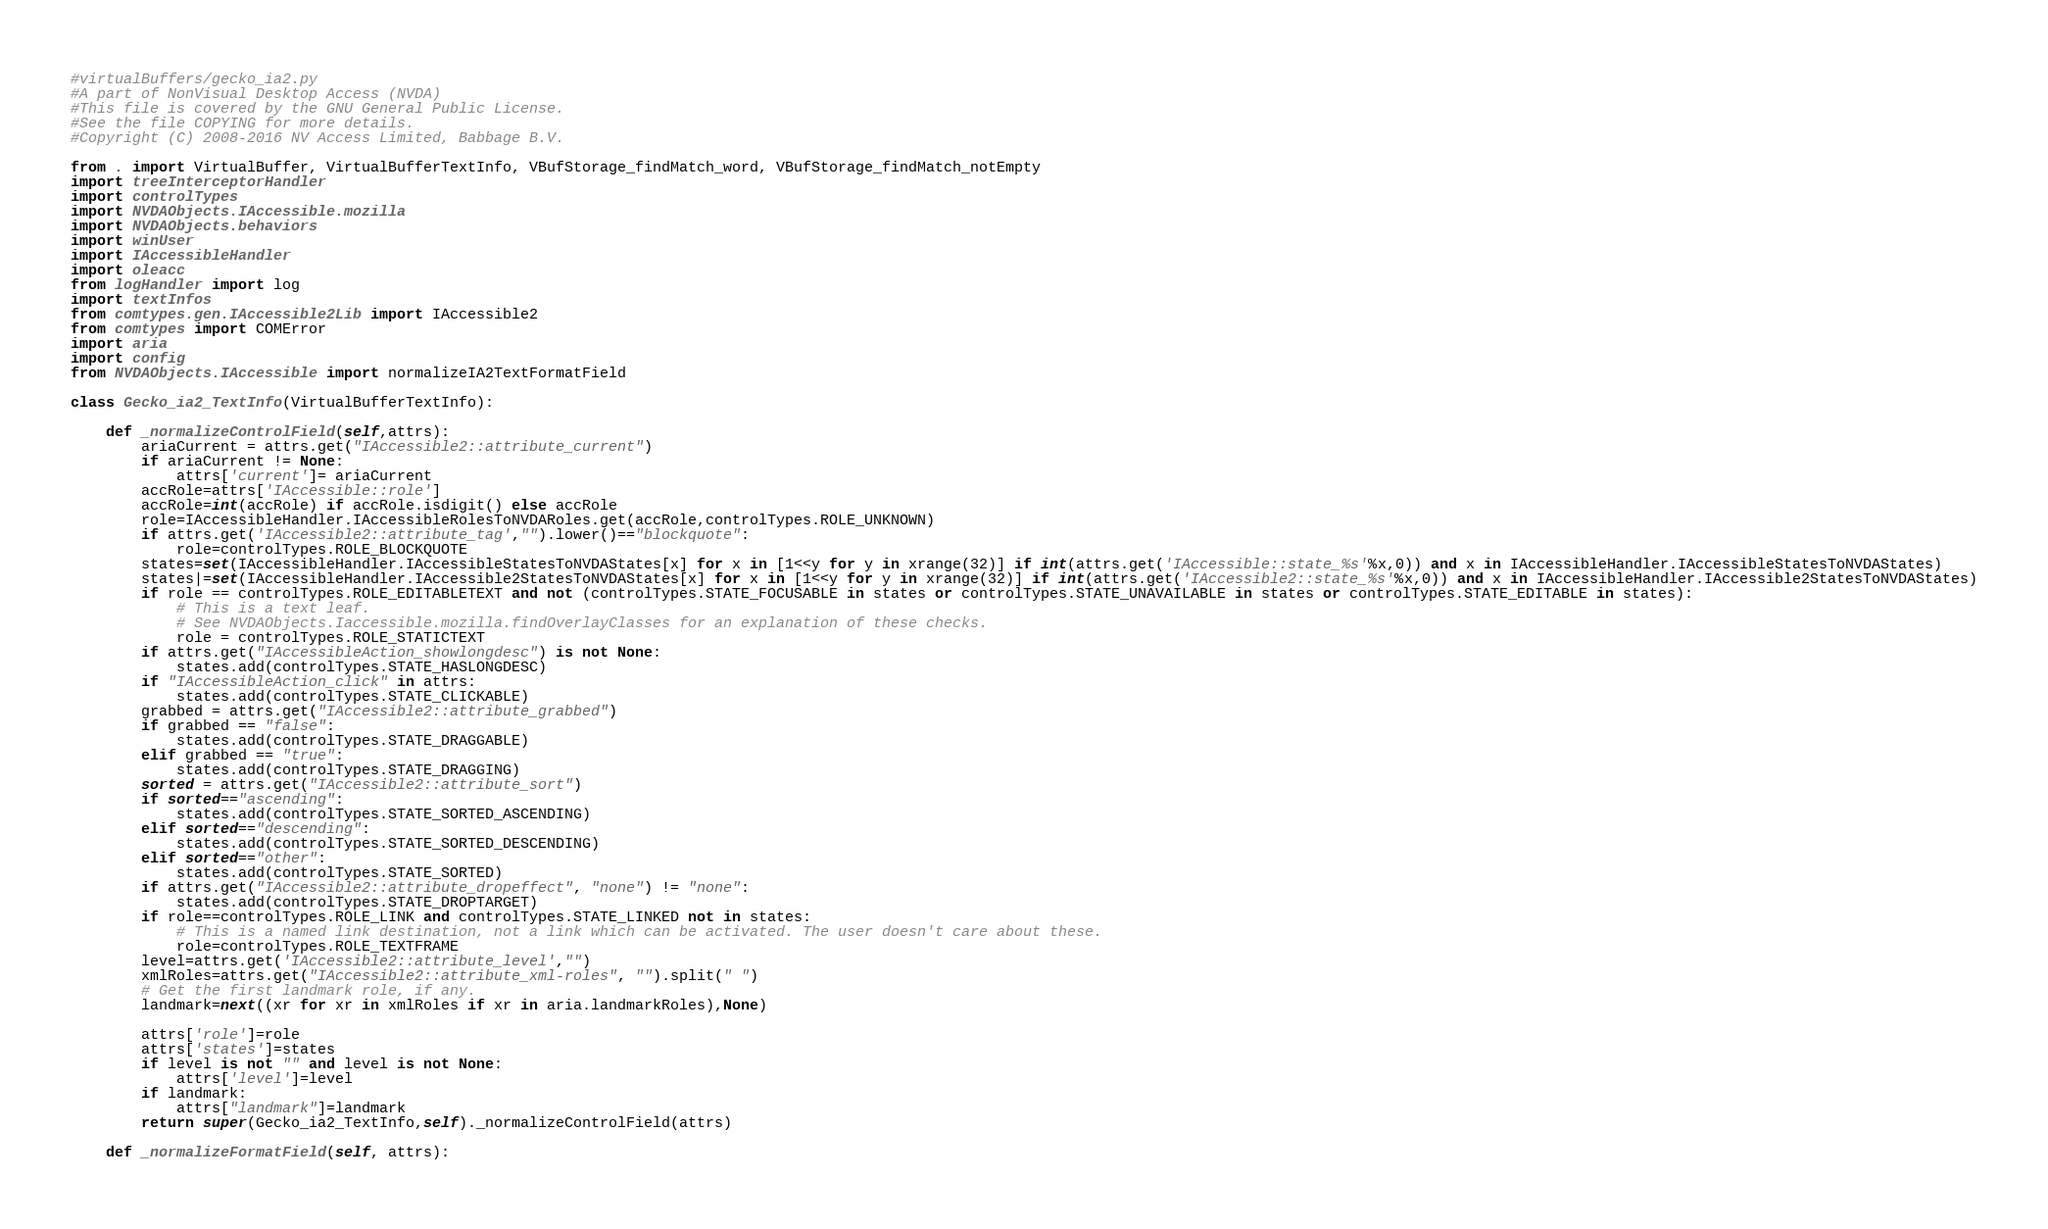Convert code to text. <code><loc_0><loc_0><loc_500><loc_500><_Python_>#virtualBuffers/gecko_ia2.py
#A part of NonVisual Desktop Access (NVDA)
#This file is covered by the GNU General Public License.
#See the file COPYING for more details.
#Copyright (C) 2008-2016 NV Access Limited, Babbage B.V.

from . import VirtualBuffer, VirtualBufferTextInfo, VBufStorage_findMatch_word, VBufStorage_findMatch_notEmpty
import treeInterceptorHandler
import controlTypes
import NVDAObjects.IAccessible.mozilla
import NVDAObjects.behaviors
import winUser
import IAccessibleHandler
import oleacc
from logHandler import log
import textInfos
from comtypes.gen.IAccessible2Lib import IAccessible2
from comtypes import COMError
import aria
import config
from NVDAObjects.IAccessible import normalizeIA2TextFormatField

class Gecko_ia2_TextInfo(VirtualBufferTextInfo):

	def _normalizeControlField(self,attrs):
		ariaCurrent = attrs.get("IAccessible2::attribute_current")
		if ariaCurrent != None:
			attrs['current']= ariaCurrent
		accRole=attrs['IAccessible::role']
		accRole=int(accRole) if accRole.isdigit() else accRole
		role=IAccessibleHandler.IAccessibleRolesToNVDARoles.get(accRole,controlTypes.ROLE_UNKNOWN)
		if attrs.get('IAccessible2::attribute_tag',"").lower()=="blockquote":
			role=controlTypes.ROLE_BLOCKQUOTE
		states=set(IAccessibleHandler.IAccessibleStatesToNVDAStates[x] for x in [1<<y for y in xrange(32)] if int(attrs.get('IAccessible::state_%s'%x,0)) and x in IAccessibleHandler.IAccessibleStatesToNVDAStates)
		states|=set(IAccessibleHandler.IAccessible2StatesToNVDAStates[x] for x in [1<<y for y in xrange(32)] if int(attrs.get('IAccessible2::state_%s'%x,0)) and x in IAccessibleHandler.IAccessible2StatesToNVDAStates)
		if role == controlTypes.ROLE_EDITABLETEXT and not (controlTypes.STATE_FOCUSABLE in states or controlTypes.STATE_UNAVAILABLE in states or controlTypes.STATE_EDITABLE in states):
			# This is a text leaf.
			# See NVDAObjects.Iaccessible.mozilla.findOverlayClasses for an explanation of these checks.
			role = controlTypes.ROLE_STATICTEXT
		if attrs.get("IAccessibleAction_showlongdesc") is not None:
			states.add(controlTypes.STATE_HASLONGDESC)
		if "IAccessibleAction_click" in attrs:
			states.add(controlTypes.STATE_CLICKABLE)
		grabbed = attrs.get("IAccessible2::attribute_grabbed")
		if grabbed == "false":
			states.add(controlTypes.STATE_DRAGGABLE)
		elif grabbed == "true":
			states.add(controlTypes.STATE_DRAGGING)
		sorted = attrs.get("IAccessible2::attribute_sort")
		if sorted=="ascending":
			states.add(controlTypes.STATE_SORTED_ASCENDING)
		elif sorted=="descending":
			states.add(controlTypes.STATE_SORTED_DESCENDING)
		elif sorted=="other":
			states.add(controlTypes.STATE_SORTED)
		if attrs.get("IAccessible2::attribute_dropeffect", "none") != "none":
			states.add(controlTypes.STATE_DROPTARGET)
		if role==controlTypes.ROLE_LINK and controlTypes.STATE_LINKED not in states:
			# This is a named link destination, not a link which can be activated. The user doesn't care about these.
			role=controlTypes.ROLE_TEXTFRAME
		level=attrs.get('IAccessible2::attribute_level',"")
		xmlRoles=attrs.get("IAccessible2::attribute_xml-roles", "").split(" ")
		# Get the first landmark role, if any.
		landmark=next((xr for xr in xmlRoles if xr in aria.landmarkRoles),None)

		attrs['role']=role
		attrs['states']=states
		if level is not "" and level is not None:
			attrs['level']=level
		if landmark:
			attrs["landmark"]=landmark
		return super(Gecko_ia2_TextInfo,self)._normalizeControlField(attrs)

	def _normalizeFormatField(self, attrs):</code> 